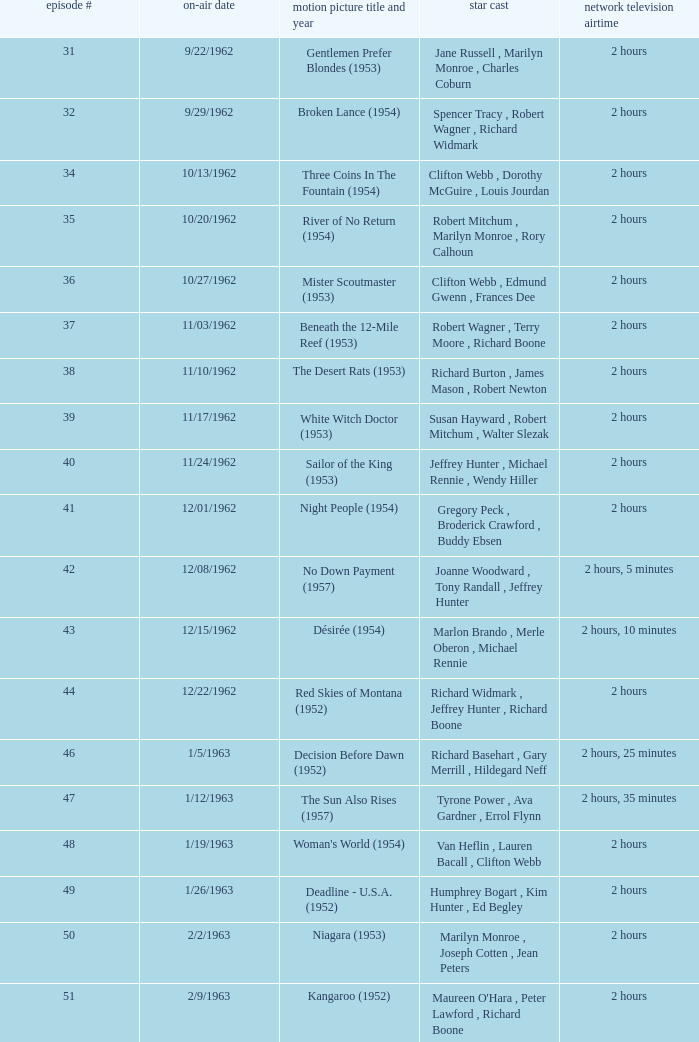Who was the cast on the 3/23/1963 episode? Dana Wynter , Mel Ferrer , Theodore Bikel. 